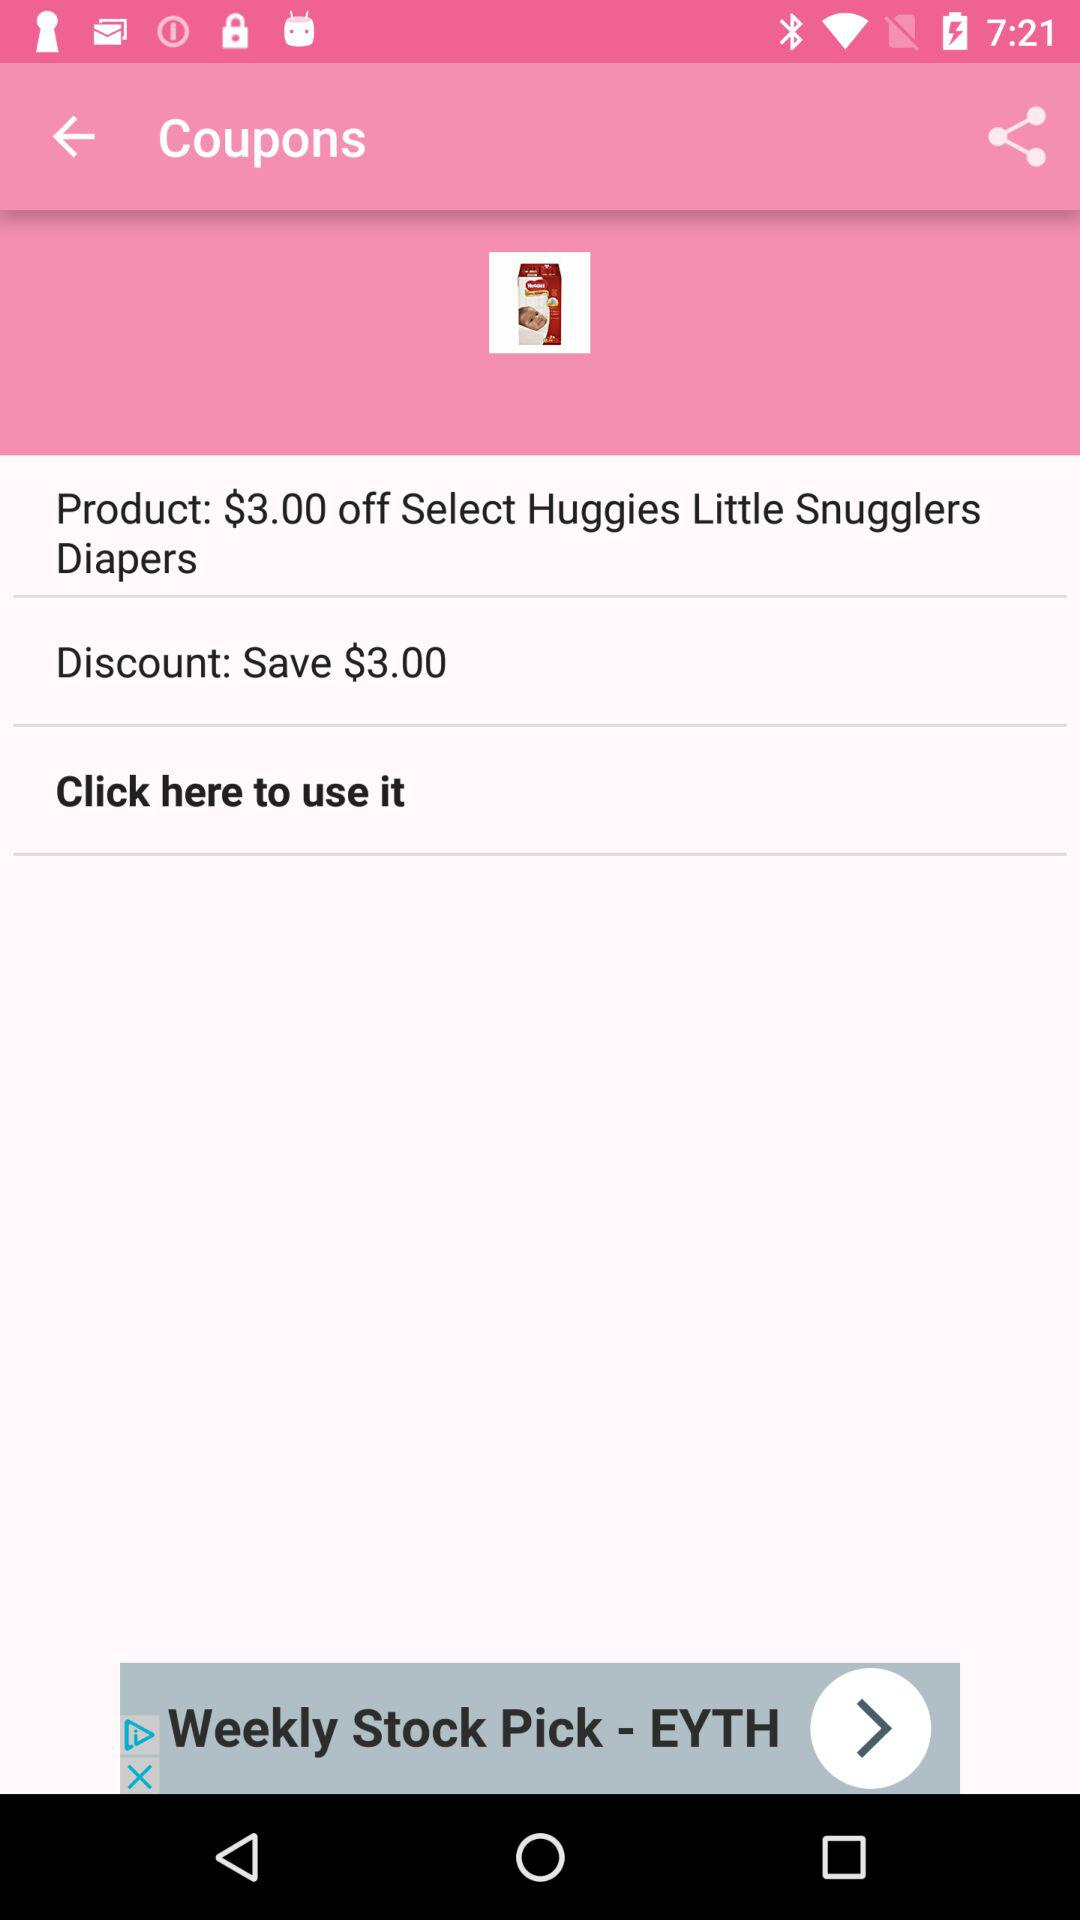How much does the coupon save?
Answer the question using a single word or phrase. $3.00 